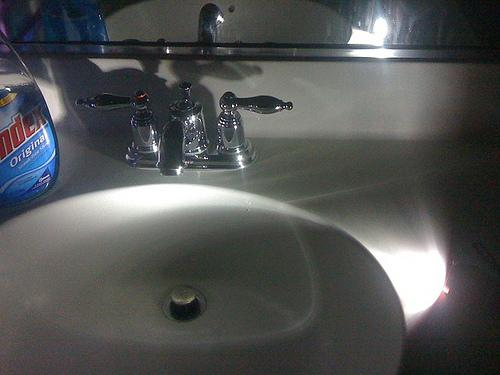Explain the appearance and details of the Windex bottle. The Windex bottle is a plastic bottle with blue solution inside. It has the word "original" printed on it, and it's meant for mirror cleaning. Count the number of metallic materials and specify their types. There are 5 metallic materials: chrome water faucet, stainless steel fittings, silver stopper, metal faucets, and stainless steel faucet. Identify the primary object and its color in the scene. The primary object is a white sink in the bathroom. Give a detailed account of the faucet and its features. The faucet is glossy, made of stainless steel, and has two metal handles for hot and cold water. There is a shiny curved faucet head, and a pull-up and down knob for the sink's stopper. Describe the lighting situation in the image. The image has a bright light and multiple light reflections on various surfaces. Are there any reflections mentioned in the image descriptions? If so, what objects are reflected? Yes, there are reflections of the Windex bottle, faucet, and overflow hole in the sink reflected in the mirror. What type of cleaning solution can be found in the image? Bottle of Windex cleaning solution. Examine the image and determine how the bathroom appears. Does it seem clean or dirty? The bathroom appears clean, with a clean sink and freshly cleaned surfaces. Analyze the image and describe the overall sentiment it evokes. The image evokes a feeling of cleanliness and freshness, with a clean and well-lit bathroom. Can you see the green cold water button on top of the faucet? The cold water button is actually blue, not green. Does the stainless steel faucet have a matte finish? The faucet is actually described as glossy, not matte. Is there a square white sink in the bathroom? The sink in the bathroom is round white, not square white. Is the reflection of the faucet in the mirror purple? The reflection of the faucet in the mirror is mentioned, but its color is not stated. It would be misleading to assume it's purple. Is the word "original" printed on the bottle in blue color? The word "original" is printed on the bottle, but the color is not mentioned, so it could be misleading to assume it's blue. Is the Windex bottle's cleaning solution red? The Windex bottle actually contains a blue solution, not a red one. 